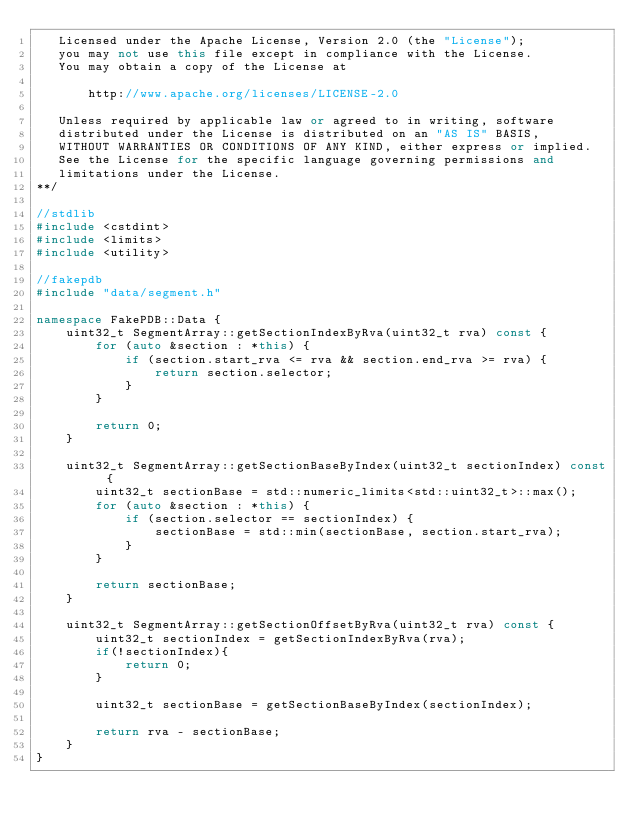<code> <loc_0><loc_0><loc_500><loc_500><_C++_>   Licensed under the Apache License, Version 2.0 (the "License");
   you may not use this file except in compliance with the License.
   You may obtain a copy of the License at

       http://www.apache.org/licenses/LICENSE-2.0

   Unless required by applicable law or agreed to in writing, software
   distributed under the License is distributed on an "AS IS" BASIS,
   WITHOUT WARRANTIES OR CONDITIONS OF ANY KIND, either express or implied.
   See the License for the specific language governing permissions and
   limitations under the License.
**/

//stdlib
#include <cstdint>
#include <limits>
#include <utility>

//fakepdb
#include "data/segment.h"

namespace FakePDB::Data {
    uint32_t SegmentArray::getSectionIndexByRva(uint32_t rva) const {
        for (auto &section : *this) {
            if (section.start_rva <= rva && section.end_rva >= rva) {
                return section.selector;
            }
        }

        return 0;
    }

    uint32_t SegmentArray::getSectionBaseByIndex(uint32_t sectionIndex) const {
        uint32_t sectionBase = std::numeric_limits<std::uint32_t>::max();
        for (auto &section : *this) {
            if (section.selector == sectionIndex) {
                sectionBase = std::min(sectionBase, section.start_rva);
            }
        }

        return sectionBase;
    }

    uint32_t SegmentArray::getSectionOffsetByRva(uint32_t rva) const {
        uint32_t sectionIndex = getSectionIndexByRva(rva);
        if(!sectionIndex){
            return 0;
        }

        uint32_t sectionBase = getSectionBaseByIndex(sectionIndex);

        return rva - sectionBase;
    }
}
</code> 